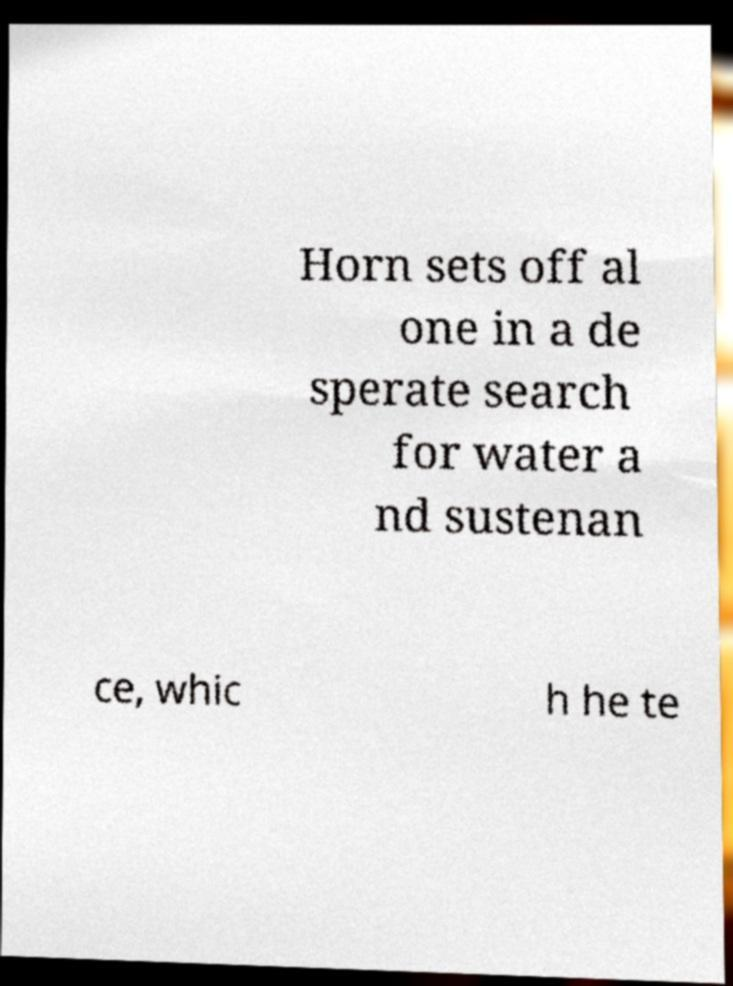What messages or text are displayed in this image? I need them in a readable, typed format. Horn sets off al one in a de sperate search for water a nd sustenan ce, whic h he te 